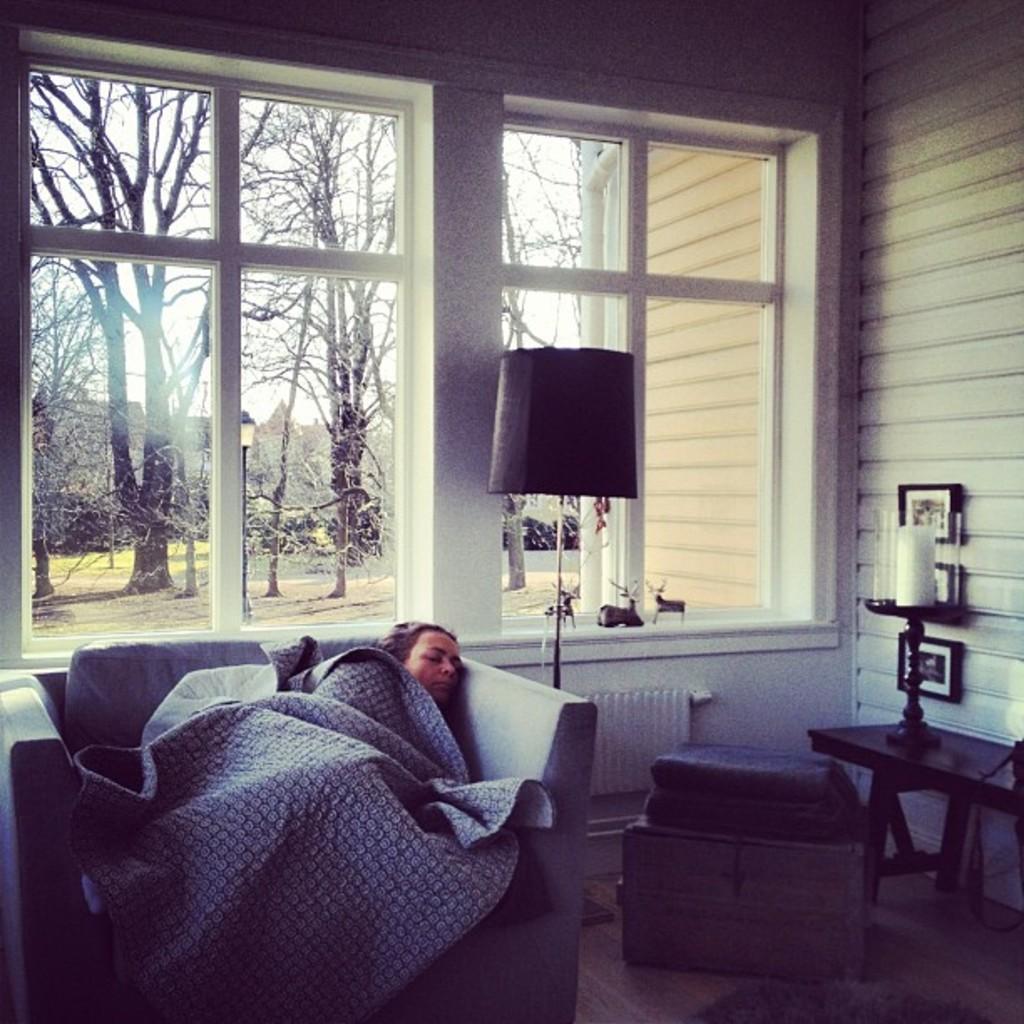Can you describe this image briefly? A woman is sleeping in the sofa there is a lamp and window glasses and outside the window there are trees and in the right it's a wall. 